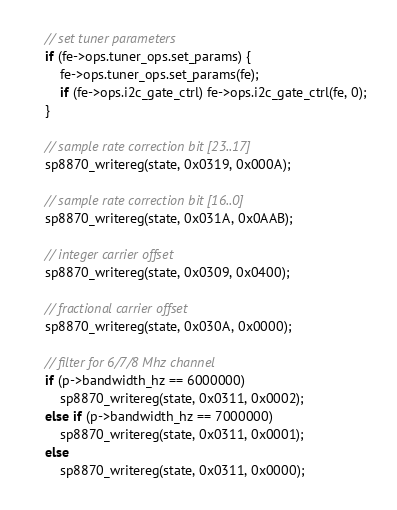<code> <loc_0><loc_0><loc_500><loc_500><_C_>
	// set tuner parameters
	if (fe->ops.tuner_ops.set_params) {
		fe->ops.tuner_ops.set_params(fe);
		if (fe->ops.i2c_gate_ctrl) fe->ops.i2c_gate_ctrl(fe, 0);
	}

	// sample rate correction bit [23..17]
	sp8870_writereg(state, 0x0319, 0x000A);

	// sample rate correction bit [16..0]
	sp8870_writereg(state, 0x031A, 0x0AAB);

	// integer carrier offset
	sp8870_writereg(state, 0x0309, 0x0400);

	// fractional carrier offset
	sp8870_writereg(state, 0x030A, 0x0000);

	// filter for 6/7/8 Mhz channel
	if (p->bandwidth_hz == 6000000)
		sp8870_writereg(state, 0x0311, 0x0002);
	else if (p->bandwidth_hz == 7000000)
		sp8870_writereg(state, 0x0311, 0x0001);
	else
		sp8870_writereg(state, 0x0311, 0x0000);
</code> 